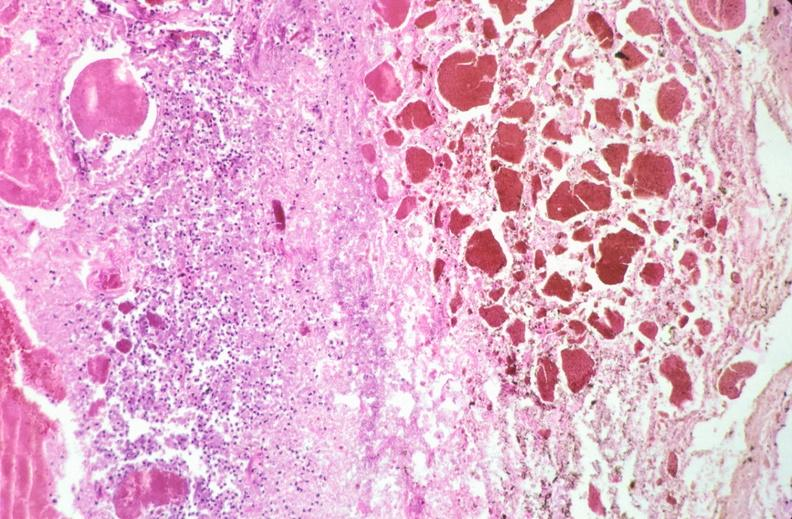where is this from?
Answer the question using a single word or phrase. Gastrointestinal system 